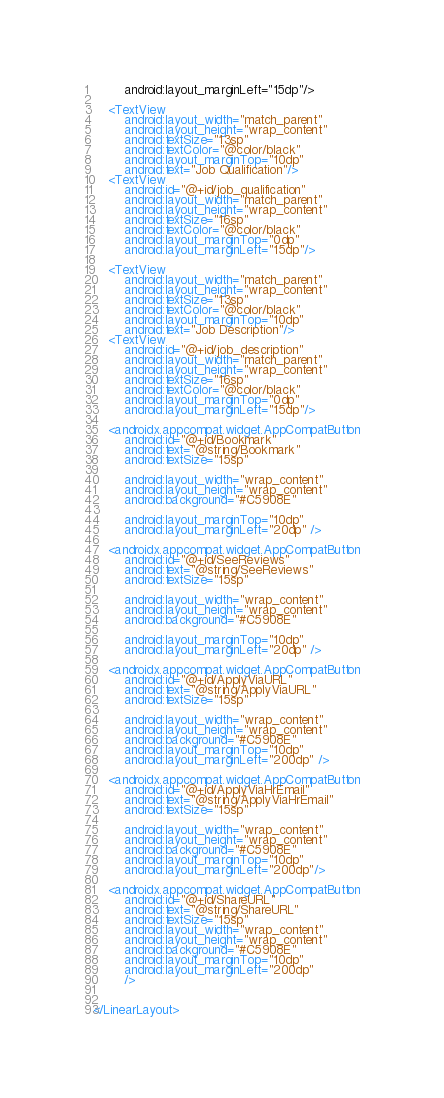Convert code to text. <code><loc_0><loc_0><loc_500><loc_500><_XML_>        android:layout_marginLeft="15dp"/>

    <TextView
        android:layout_width="match_parent"
        android:layout_height="wrap_content"
        android:textSize="13sp"
        android:textColor="@color/black"
        android:layout_marginTop="10dp"
        android:text="Job Qualification"/>
    <TextView
        android:id="@+id/job_qualification"
        android:layout_width="match_parent"
        android:layout_height="wrap_content"
        android:textSize="16sp"
        android:textColor="@color/black"
        android:layout_marginTop="0dp"
        android:layout_marginLeft="15dp"/>

    <TextView
        android:layout_width="match_parent"
        android:layout_height="wrap_content"
        android:textSize="13sp"
        android:textColor="@color/black"
        android:layout_marginTop="10dp"
        android:text="Job Description"/>
    <TextView
        android:id="@+id/job_description"
        android:layout_width="match_parent"
        android:layout_height="wrap_content"
        android:textSize="16sp"
        android:textColor="@color/black"
        android:layout_marginTop="0dp"
        android:layout_marginLeft="15dp"/>

    <androidx.appcompat.widget.AppCompatButton
        android:id="@+id/Bookmark"
        android:text="@string/Bookmark"
        android:textSize="15sp"

        android:layout_width="wrap_content"
        android:layout_height="wrap_content"
        android:background="#C5908E"

        android:layout_marginTop="10dp"
        android:layout_marginLeft="20dp" />

    <androidx.appcompat.widget.AppCompatButton
        android:id="@+id/SeeReviews"
        android:text="@string/SeeReviews"
        android:textSize="15sp"

        android:layout_width="wrap_content"
        android:layout_height="wrap_content"
        android:background="#C5908E"

        android:layout_marginTop="10dp"
        android:layout_marginLeft="20dp" />

    <androidx.appcompat.widget.AppCompatButton
        android:id="@+id/ApplyViaURL"
        android:text="@string/ApplyViaURL"
        android:textSize="15sp"

        android:layout_width="wrap_content"
        android:layout_height="wrap_content"
        android:background="#C5908E"
        android:layout_marginTop="10dp"
        android:layout_marginLeft="200dp" />

    <androidx.appcompat.widget.AppCompatButton
        android:id="@+id/ApplyViaHrEmail"
        android:text="@string/ApplyViaHrEmail"
        android:textSize="15sp"

        android:layout_width="wrap_content"
        android:layout_height="wrap_content"
        android:background="#C5908E"
        android:layout_marginTop="10dp"
        android:layout_marginLeft="200dp"/>

    <androidx.appcompat.widget.AppCompatButton
        android:id="@+id/ShareURL"
        android:text="@string/ShareURL"
        android:textSize="15sp"
        android:layout_width="wrap_content"
        android:layout_height="wrap_content"
        android:background="#C5908E"
        android:layout_marginTop="10dp"
        android:layout_marginLeft="200dp"
        />


</LinearLayout></code> 